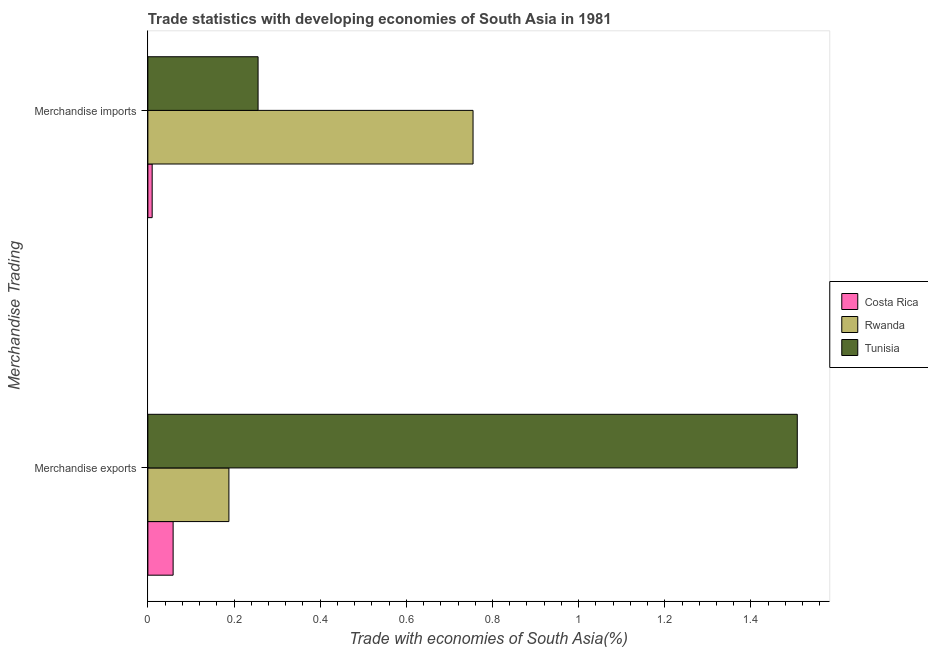How many different coloured bars are there?
Offer a terse response. 3. Are the number of bars on each tick of the Y-axis equal?
Make the answer very short. Yes. How many bars are there on the 1st tick from the bottom?
Provide a short and direct response. 3. What is the label of the 1st group of bars from the top?
Your answer should be very brief. Merchandise imports. What is the merchandise exports in Tunisia?
Ensure brevity in your answer.  1.51. Across all countries, what is the maximum merchandise imports?
Provide a short and direct response. 0.75. Across all countries, what is the minimum merchandise imports?
Your answer should be compact. 0.01. In which country was the merchandise exports maximum?
Your answer should be compact. Tunisia. In which country was the merchandise imports minimum?
Offer a very short reply. Costa Rica. What is the total merchandise imports in the graph?
Your answer should be very brief. 1.02. What is the difference between the merchandise imports in Tunisia and that in Costa Rica?
Make the answer very short. 0.25. What is the difference between the merchandise exports in Rwanda and the merchandise imports in Costa Rica?
Offer a terse response. 0.18. What is the average merchandise imports per country?
Your response must be concise. 0.34. What is the difference between the merchandise imports and merchandise exports in Tunisia?
Offer a very short reply. -1.25. What is the ratio of the merchandise exports in Costa Rica to that in Tunisia?
Your response must be concise. 0.04. In how many countries, is the merchandise exports greater than the average merchandise exports taken over all countries?
Your answer should be very brief. 1. What does the 1st bar from the top in Merchandise exports represents?
Your answer should be very brief. Tunisia. How many bars are there?
Provide a short and direct response. 6. Are all the bars in the graph horizontal?
Provide a short and direct response. Yes. Are the values on the major ticks of X-axis written in scientific E-notation?
Offer a terse response. No. Does the graph contain any zero values?
Ensure brevity in your answer.  No. Where does the legend appear in the graph?
Keep it short and to the point. Center right. How are the legend labels stacked?
Ensure brevity in your answer.  Vertical. What is the title of the graph?
Your response must be concise. Trade statistics with developing economies of South Asia in 1981. What is the label or title of the X-axis?
Make the answer very short. Trade with economies of South Asia(%). What is the label or title of the Y-axis?
Ensure brevity in your answer.  Merchandise Trading. What is the Trade with economies of South Asia(%) in Costa Rica in Merchandise exports?
Provide a short and direct response. 0.06. What is the Trade with economies of South Asia(%) in Rwanda in Merchandise exports?
Offer a terse response. 0.19. What is the Trade with economies of South Asia(%) of Tunisia in Merchandise exports?
Your answer should be compact. 1.51. What is the Trade with economies of South Asia(%) of Costa Rica in Merchandise imports?
Offer a terse response. 0.01. What is the Trade with economies of South Asia(%) of Rwanda in Merchandise imports?
Give a very brief answer. 0.75. What is the Trade with economies of South Asia(%) in Tunisia in Merchandise imports?
Keep it short and to the point. 0.26. Across all Merchandise Trading, what is the maximum Trade with economies of South Asia(%) in Costa Rica?
Make the answer very short. 0.06. Across all Merchandise Trading, what is the maximum Trade with economies of South Asia(%) in Rwanda?
Keep it short and to the point. 0.75. Across all Merchandise Trading, what is the maximum Trade with economies of South Asia(%) of Tunisia?
Make the answer very short. 1.51. Across all Merchandise Trading, what is the minimum Trade with economies of South Asia(%) of Costa Rica?
Ensure brevity in your answer.  0.01. Across all Merchandise Trading, what is the minimum Trade with economies of South Asia(%) of Rwanda?
Your answer should be very brief. 0.19. Across all Merchandise Trading, what is the minimum Trade with economies of South Asia(%) of Tunisia?
Provide a short and direct response. 0.26. What is the total Trade with economies of South Asia(%) of Costa Rica in the graph?
Ensure brevity in your answer.  0.07. What is the total Trade with economies of South Asia(%) of Rwanda in the graph?
Give a very brief answer. 0.94. What is the total Trade with economies of South Asia(%) of Tunisia in the graph?
Your response must be concise. 1.76. What is the difference between the Trade with economies of South Asia(%) of Costa Rica in Merchandise exports and that in Merchandise imports?
Offer a very short reply. 0.05. What is the difference between the Trade with economies of South Asia(%) in Rwanda in Merchandise exports and that in Merchandise imports?
Keep it short and to the point. -0.57. What is the difference between the Trade with economies of South Asia(%) in Tunisia in Merchandise exports and that in Merchandise imports?
Your answer should be very brief. 1.25. What is the difference between the Trade with economies of South Asia(%) in Costa Rica in Merchandise exports and the Trade with economies of South Asia(%) in Rwanda in Merchandise imports?
Provide a short and direct response. -0.7. What is the difference between the Trade with economies of South Asia(%) in Costa Rica in Merchandise exports and the Trade with economies of South Asia(%) in Tunisia in Merchandise imports?
Your answer should be compact. -0.2. What is the difference between the Trade with economies of South Asia(%) in Rwanda in Merchandise exports and the Trade with economies of South Asia(%) in Tunisia in Merchandise imports?
Your response must be concise. -0.07. What is the average Trade with economies of South Asia(%) in Costa Rica per Merchandise Trading?
Offer a very short reply. 0.03. What is the average Trade with economies of South Asia(%) of Rwanda per Merchandise Trading?
Keep it short and to the point. 0.47. What is the average Trade with economies of South Asia(%) in Tunisia per Merchandise Trading?
Offer a terse response. 0.88. What is the difference between the Trade with economies of South Asia(%) in Costa Rica and Trade with economies of South Asia(%) in Rwanda in Merchandise exports?
Make the answer very short. -0.13. What is the difference between the Trade with economies of South Asia(%) of Costa Rica and Trade with economies of South Asia(%) of Tunisia in Merchandise exports?
Ensure brevity in your answer.  -1.45. What is the difference between the Trade with economies of South Asia(%) in Rwanda and Trade with economies of South Asia(%) in Tunisia in Merchandise exports?
Your response must be concise. -1.32. What is the difference between the Trade with economies of South Asia(%) of Costa Rica and Trade with economies of South Asia(%) of Rwanda in Merchandise imports?
Your answer should be compact. -0.74. What is the difference between the Trade with economies of South Asia(%) in Costa Rica and Trade with economies of South Asia(%) in Tunisia in Merchandise imports?
Offer a terse response. -0.25. What is the difference between the Trade with economies of South Asia(%) of Rwanda and Trade with economies of South Asia(%) of Tunisia in Merchandise imports?
Your answer should be compact. 0.5. What is the ratio of the Trade with economies of South Asia(%) in Costa Rica in Merchandise exports to that in Merchandise imports?
Provide a short and direct response. 5.86. What is the ratio of the Trade with economies of South Asia(%) of Rwanda in Merchandise exports to that in Merchandise imports?
Provide a short and direct response. 0.25. What is the ratio of the Trade with economies of South Asia(%) of Tunisia in Merchandise exports to that in Merchandise imports?
Ensure brevity in your answer.  5.89. What is the difference between the highest and the second highest Trade with economies of South Asia(%) in Costa Rica?
Provide a succinct answer. 0.05. What is the difference between the highest and the second highest Trade with economies of South Asia(%) in Rwanda?
Your response must be concise. 0.57. What is the difference between the highest and the second highest Trade with economies of South Asia(%) of Tunisia?
Offer a very short reply. 1.25. What is the difference between the highest and the lowest Trade with economies of South Asia(%) of Costa Rica?
Your answer should be compact. 0.05. What is the difference between the highest and the lowest Trade with economies of South Asia(%) in Rwanda?
Make the answer very short. 0.57. What is the difference between the highest and the lowest Trade with economies of South Asia(%) of Tunisia?
Your response must be concise. 1.25. 